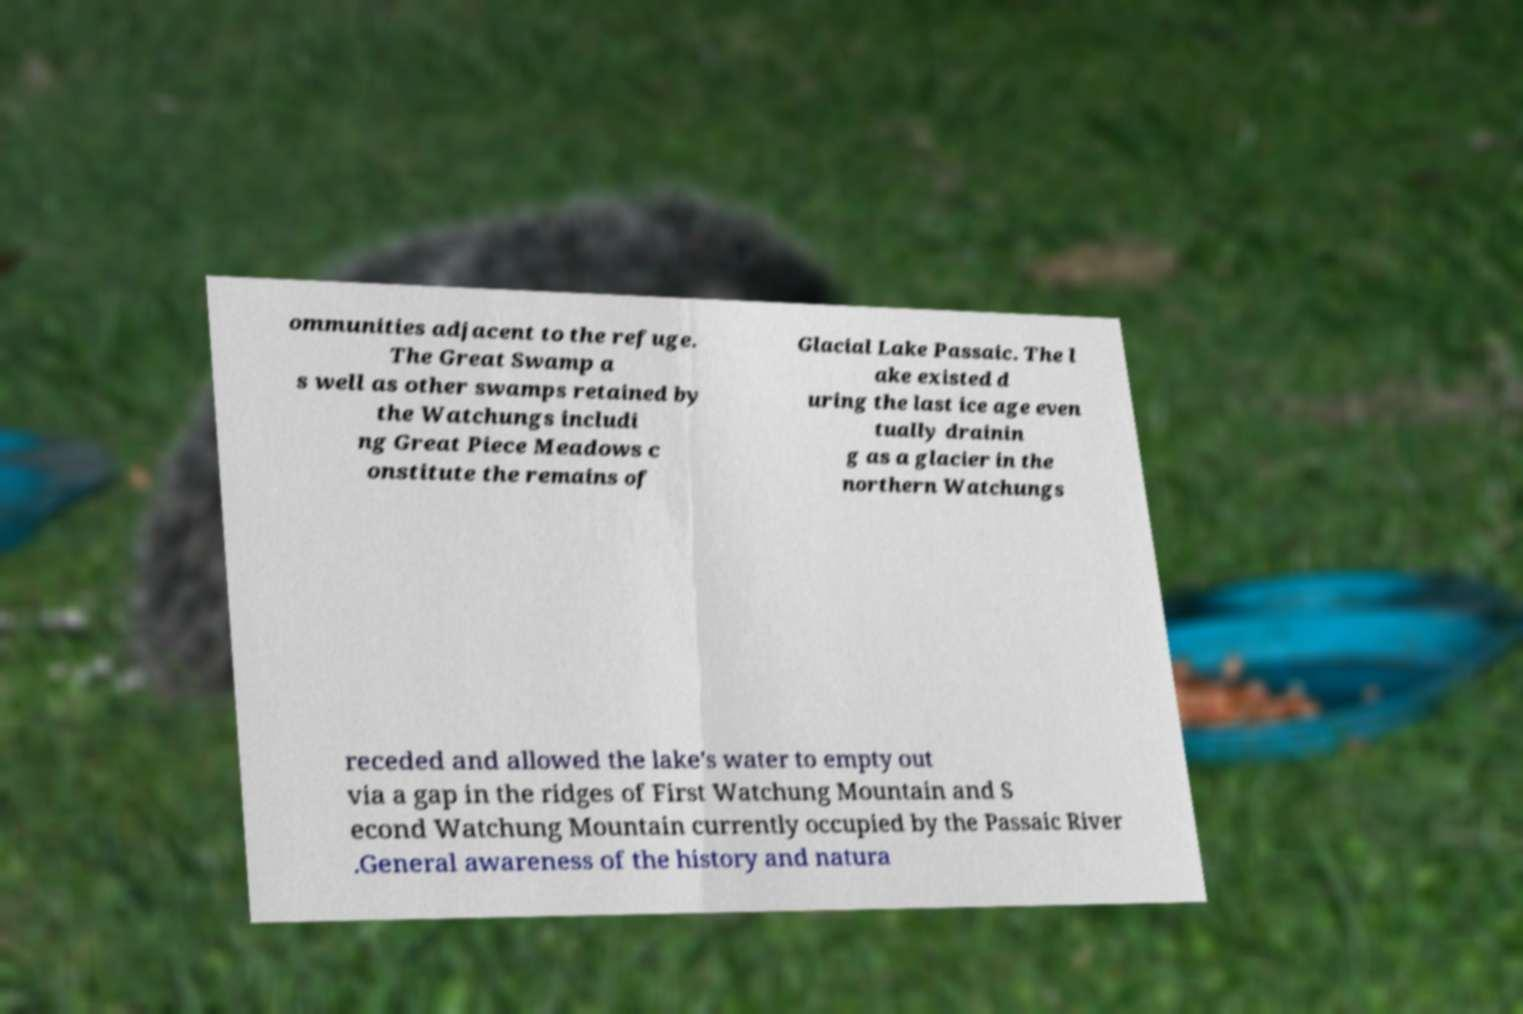Could you assist in decoding the text presented in this image and type it out clearly? ommunities adjacent to the refuge. The Great Swamp a s well as other swamps retained by the Watchungs includi ng Great Piece Meadows c onstitute the remains of Glacial Lake Passaic. The l ake existed d uring the last ice age even tually drainin g as a glacier in the northern Watchungs receded and allowed the lake's water to empty out via a gap in the ridges of First Watchung Mountain and S econd Watchung Mountain currently occupied by the Passaic River .General awareness of the history and natura 